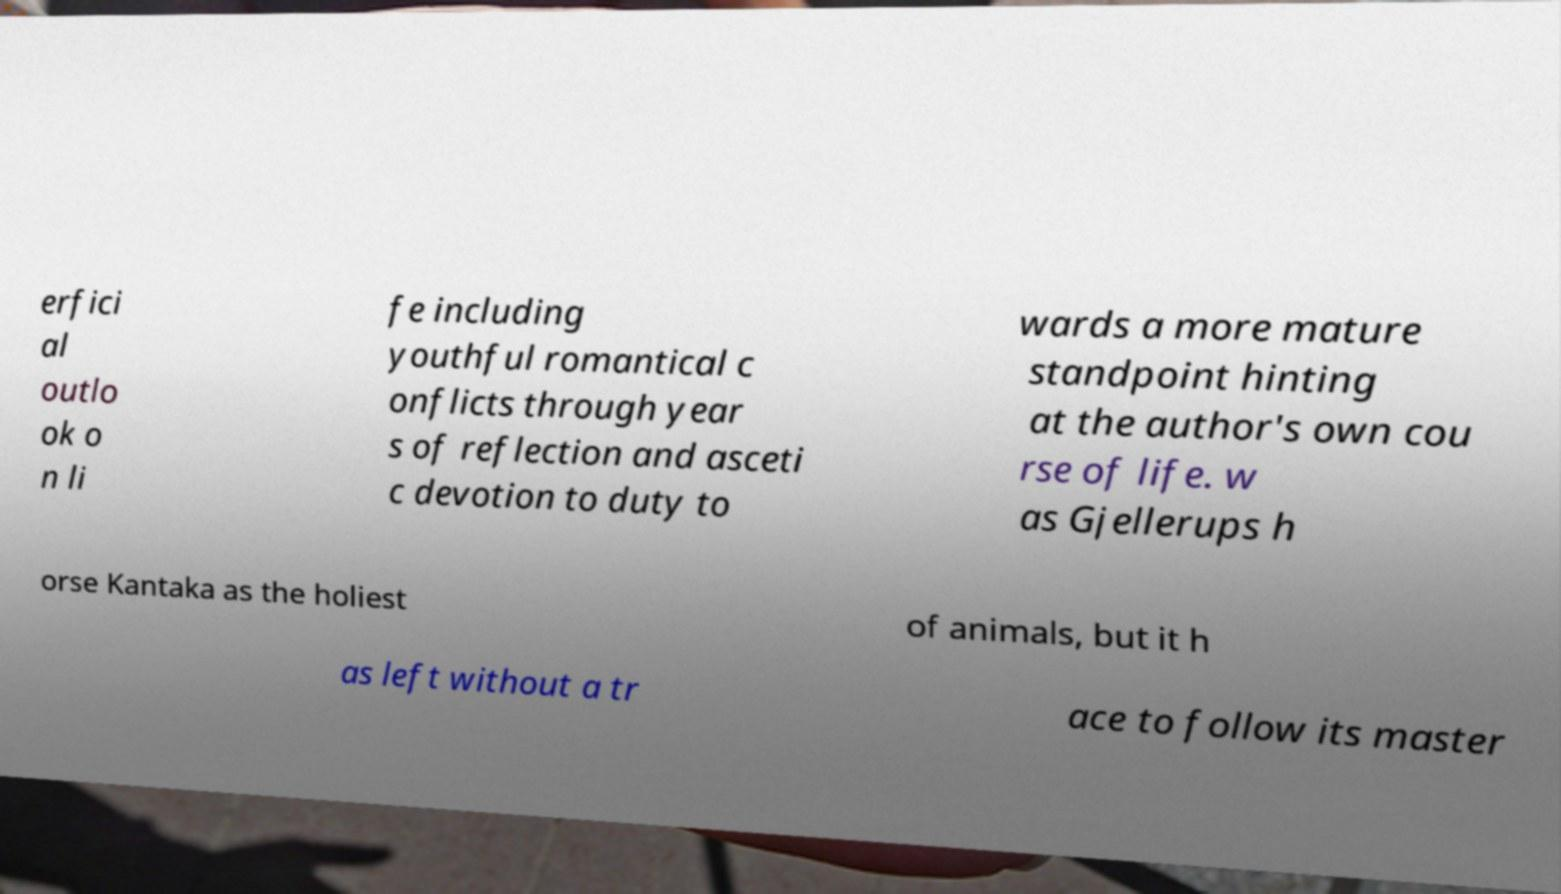For documentation purposes, I need the text within this image transcribed. Could you provide that? erfici al outlo ok o n li fe including youthful romantical c onflicts through year s of reflection and asceti c devotion to duty to wards a more mature standpoint hinting at the author's own cou rse of life. w as Gjellerups h orse Kantaka as the holiest of animals, but it h as left without a tr ace to follow its master 